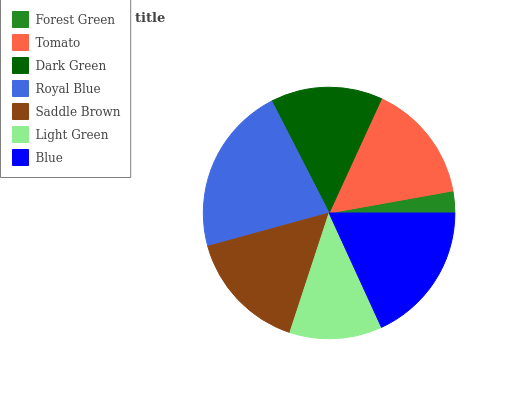Is Forest Green the minimum?
Answer yes or no. Yes. Is Royal Blue the maximum?
Answer yes or no. Yes. Is Tomato the minimum?
Answer yes or no. No. Is Tomato the maximum?
Answer yes or no. No. Is Tomato greater than Forest Green?
Answer yes or no. Yes. Is Forest Green less than Tomato?
Answer yes or no. Yes. Is Forest Green greater than Tomato?
Answer yes or no. No. Is Tomato less than Forest Green?
Answer yes or no. No. Is Tomato the high median?
Answer yes or no. Yes. Is Tomato the low median?
Answer yes or no. Yes. Is Forest Green the high median?
Answer yes or no. No. Is Light Green the low median?
Answer yes or no. No. 